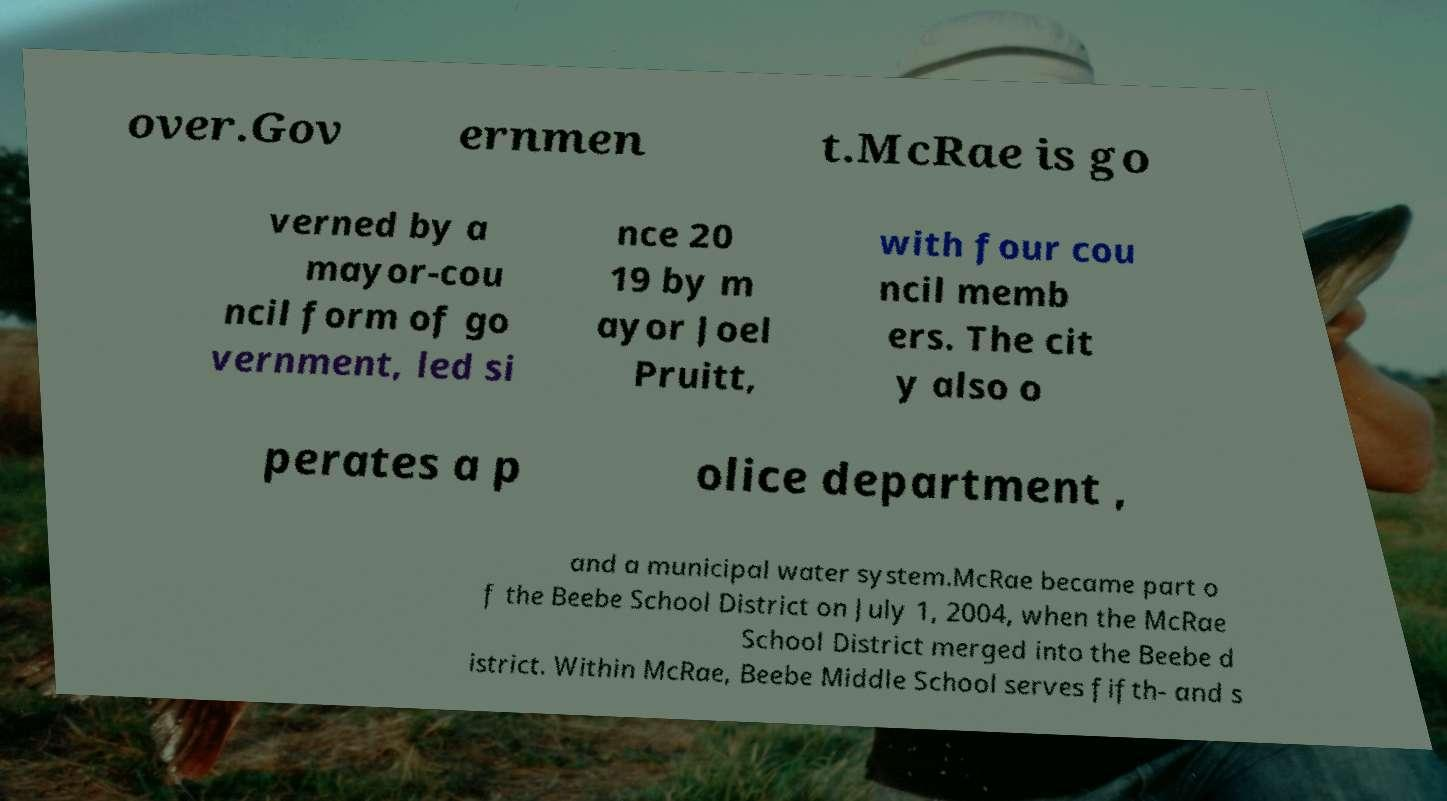For documentation purposes, I need the text within this image transcribed. Could you provide that? over.Gov ernmen t.McRae is go verned by a mayor-cou ncil form of go vernment, led si nce 20 19 by m ayor Joel Pruitt, with four cou ncil memb ers. The cit y also o perates a p olice department , and a municipal water system.McRae became part o f the Beebe School District on July 1, 2004, when the McRae School District merged into the Beebe d istrict. Within McRae, Beebe Middle School serves fifth- and s 